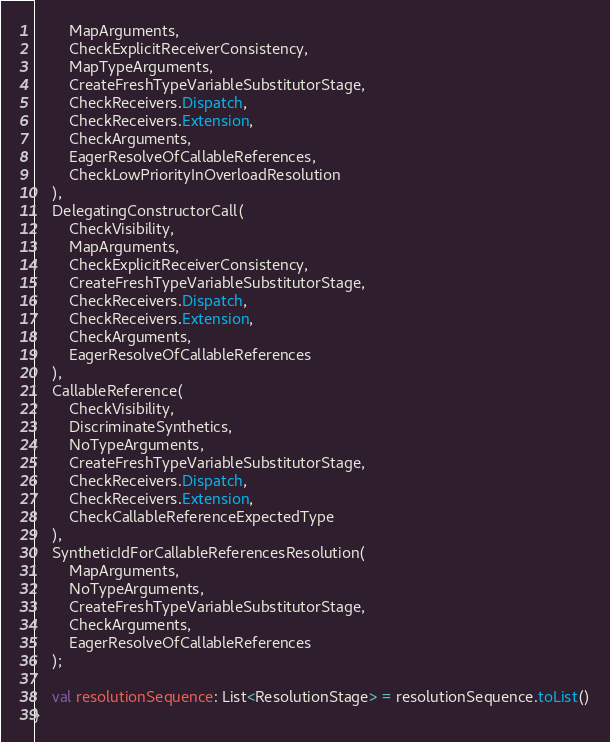Convert code to text. <code><loc_0><loc_0><loc_500><loc_500><_Kotlin_>        MapArguments,
        CheckExplicitReceiverConsistency,
        MapTypeArguments,
        CreateFreshTypeVariableSubstitutorStage,
        CheckReceivers.Dispatch,
        CheckReceivers.Extension,
        CheckArguments,
        EagerResolveOfCallableReferences,
        CheckLowPriorityInOverloadResolution
    ),
    DelegatingConstructorCall(
        CheckVisibility,
        MapArguments,
        CheckExplicitReceiverConsistency,
        CreateFreshTypeVariableSubstitutorStage,
        CheckReceivers.Dispatch,
        CheckReceivers.Extension,
        CheckArguments,
        EagerResolveOfCallableReferences
    ),
    CallableReference(
        CheckVisibility,
        DiscriminateSynthetics,
        NoTypeArguments,
        CreateFreshTypeVariableSubstitutorStage,
        CheckReceivers.Dispatch,
        CheckReceivers.Extension,
        CheckCallableReferenceExpectedType
    ),
    SyntheticIdForCallableReferencesResolution(
        MapArguments,
        NoTypeArguments,
        CreateFreshTypeVariableSubstitutorStage,
        CheckArguments,
        EagerResolveOfCallableReferences
    );

    val resolutionSequence: List<ResolutionStage> = resolutionSequence.toList()
}
</code> 